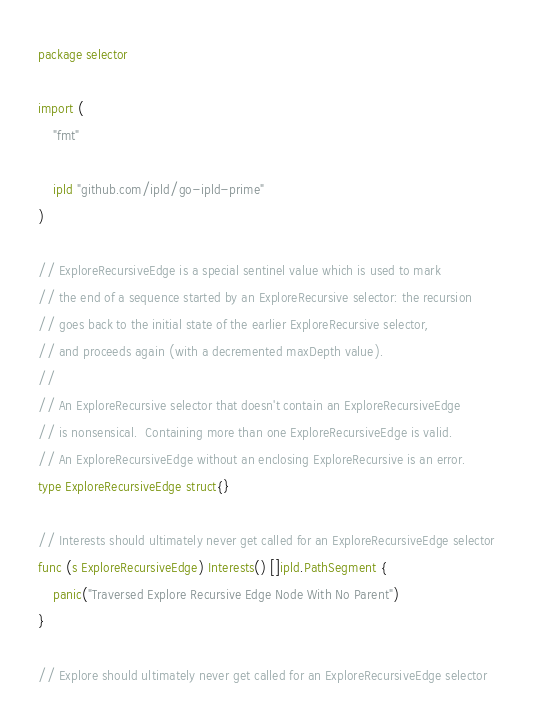<code> <loc_0><loc_0><loc_500><loc_500><_Go_>package selector

import (
	"fmt"

	ipld "github.com/ipld/go-ipld-prime"
)

// ExploreRecursiveEdge is a special sentinel value which is used to mark
// the end of a sequence started by an ExploreRecursive selector: the recursion
// goes back to the initial state of the earlier ExploreRecursive selector,
// and proceeds again (with a decremented maxDepth value).
//
// An ExploreRecursive selector that doesn't contain an ExploreRecursiveEdge
// is nonsensical.  Containing more than one ExploreRecursiveEdge is valid.
// An ExploreRecursiveEdge without an enclosing ExploreRecursive is an error.
type ExploreRecursiveEdge struct{}

// Interests should ultimately never get called for an ExploreRecursiveEdge selector
func (s ExploreRecursiveEdge) Interests() []ipld.PathSegment {
	panic("Traversed Explore Recursive Edge Node With No Parent")
}

// Explore should ultimately never get called for an ExploreRecursiveEdge selector</code> 